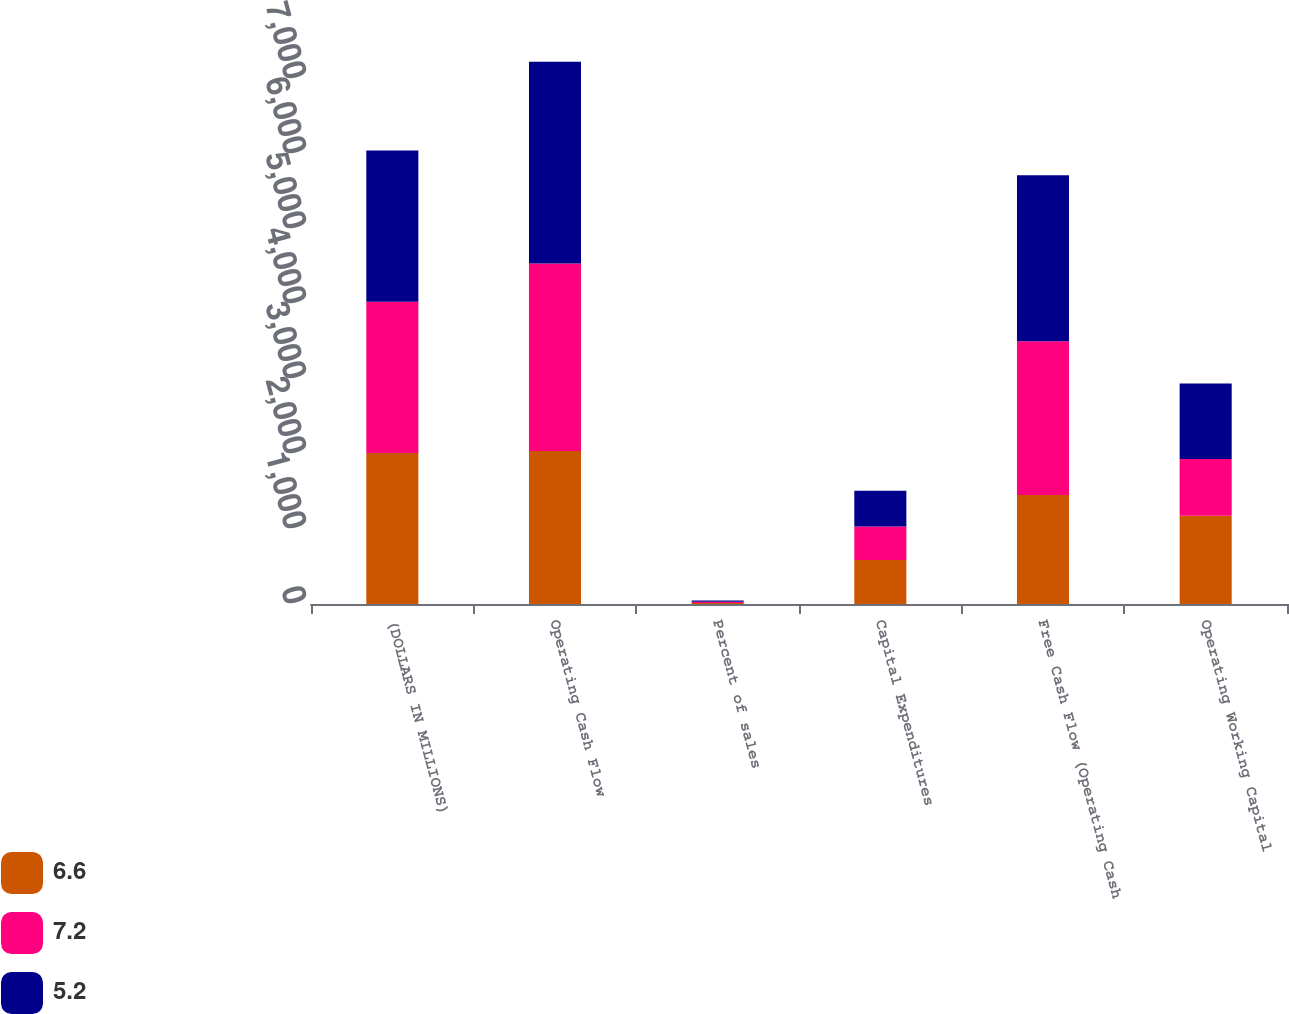<chart> <loc_0><loc_0><loc_500><loc_500><stacked_bar_chart><ecel><fcel>(DOLLARS IN MILLIONS)<fcel>Operating Cash Flow<fcel>Percent of sales<fcel>Capital Expenditures<fcel>Free Cash Flow (Operating Cash<fcel>Operating Working Capital<nl><fcel>6.6<fcel>2015<fcel>2040<fcel>12.6<fcel>588<fcel>1452<fcel>1177<nl><fcel>7.2<fcel>2016<fcel>2499<fcel>17.2<fcel>447<fcel>2052<fcel>755<nl><fcel>5.2<fcel>2017<fcel>2690<fcel>17.6<fcel>476<fcel>2214<fcel>1007<nl></chart> 